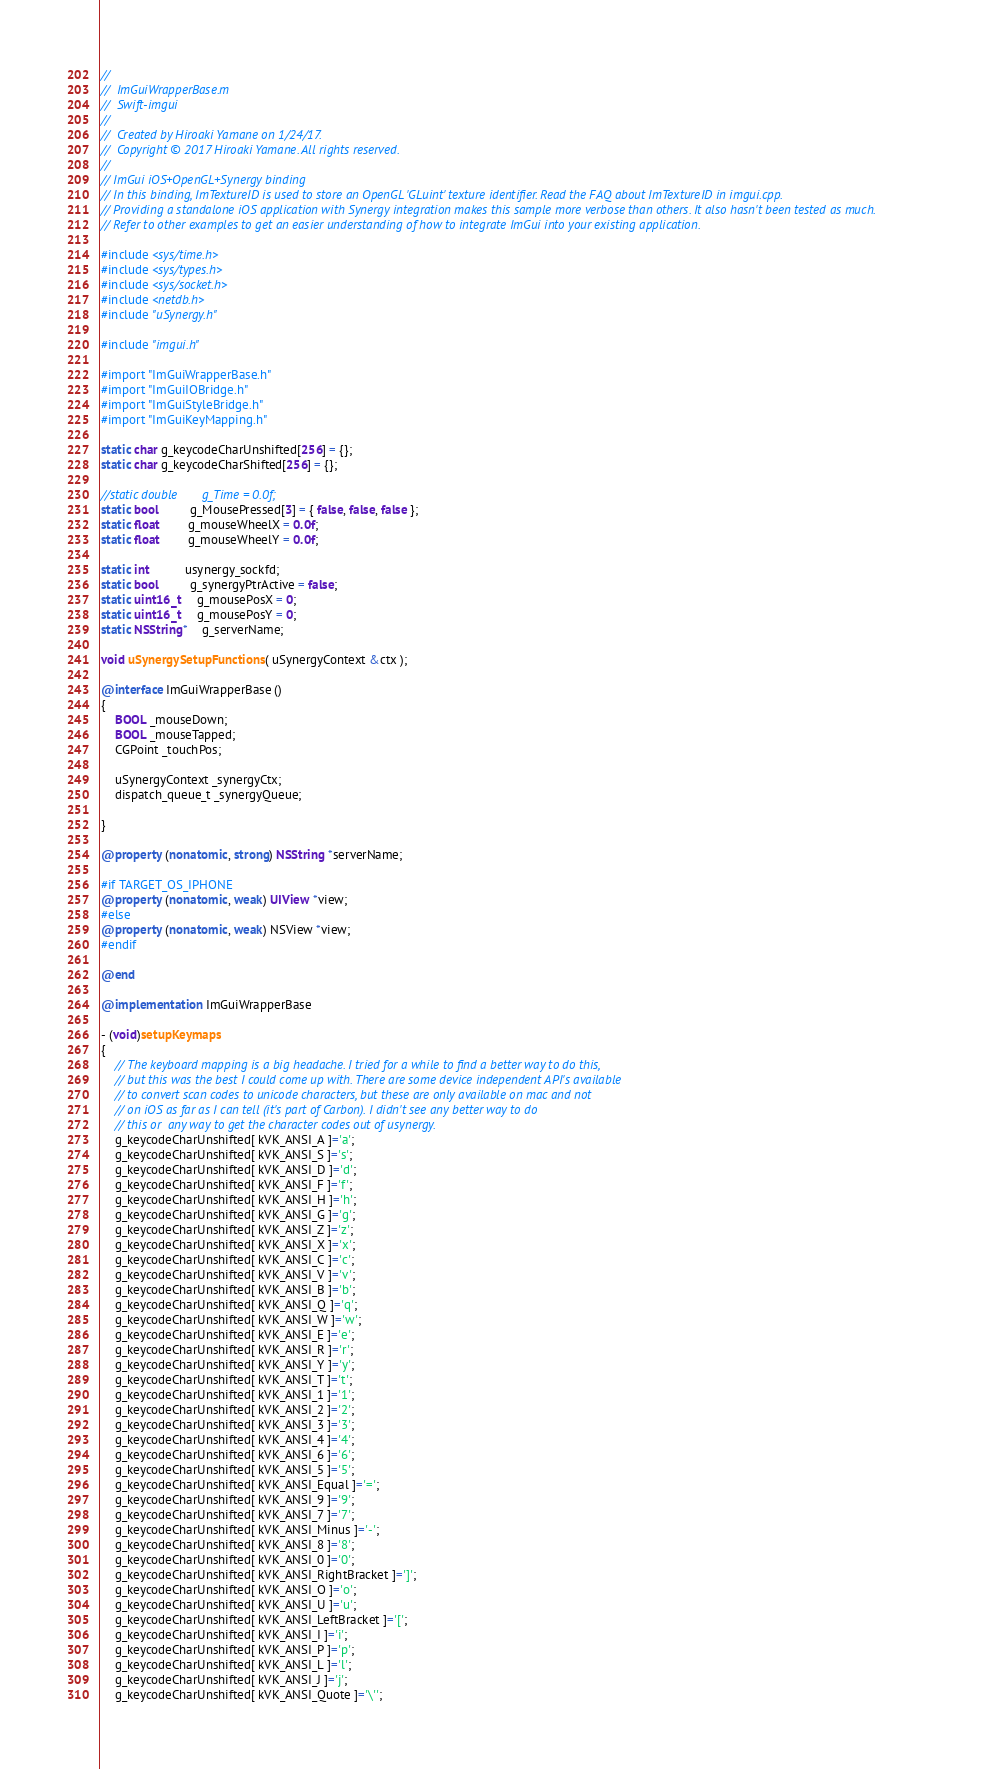Convert code to text. <code><loc_0><loc_0><loc_500><loc_500><_ObjectiveC_>//
//  ImGuiWrapperBase.m
//  Swift-imgui
//
//  Created by Hiroaki Yamane on 1/24/17.
//  Copyright © 2017 Hiroaki Yamane. All rights reserved.
//
// ImGui iOS+OpenGL+Synergy binding
// In this binding, ImTextureID is used to store an OpenGL 'GLuint' texture identifier. Read the FAQ about ImTextureID in imgui.cpp.
// Providing a standalone iOS application with Synergy integration makes this sample more verbose than others. It also hasn't been tested as much.
// Refer to other examples to get an easier understanding of how to integrate ImGui into your existing application.

#include <sys/time.h>
#include <sys/types.h>
#include <sys/socket.h>
#include <netdb.h>
#include "uSynergy.h"

#include "imgui.h"

#import "ImGuiWrapperBase.h"
#import "ImGuiIOBridge.h"
#import "ImGuiStyleBridge.h"
#import "ImGuiKeyMapping.h"

static char g_keycodeCharUnshifted[256] = {};
static char g_keycodeCharShifted[256] = {};

//static double       g_Time = 0.0f;
static bool         g_MousePressed[3] = { false, false, false };
static float        g_mouseWheelX = 0.0f;
static float        g_mouseWheelY = 0.0f;

static int          usynergy_sockfd;
static bool         g_synergyPtrActive = false;
static uint16_t     g_mousePosX = 0;
static uint16_t     g_mousePosY = 0;
static NSString*    g_serverName;

void uSynergySetupFunctions( uSynergyContext &ctx );

@interface ImGuiWrapperBase ()
{
    BOOL _mouseDown;
    BOOL _mouseTapped;
    CGPoint _touchPos;
    
    uSynergyContext _synergyCtx;
    dispatch_queue_t _synergyQueue;
    
}

@property (nonatomic, strong) NSString *serverName;

#if TARGET_OS_IPHONE
@property (nonatomic, weak) UIView *view;
#else
@property (nonatomic, weak) NSView *view;
#endif

@end

@implementation ImGuiWrapperBase

- (void)setupKeymaps
{
    // The keyboard mapping is a big headache. I tried for a while to find a better way to do this,
    // but this was the best I could come up with. There are some device independent API's available
    // to convert scan codes to unicode characters, but these are only available on mac and not
    // on iOS as far as I can tell (it's part of Carbon). I didn't see any better way to do
    // this or  any way to get the character codes out of usynergy.
    g_keycodeCharUnshifted[ kVK_ANSI_A ]='a';
    g_keycodeCharUnshifted[ kVK_ANSI_S ]='s';
    g_keycodeCharUnshifted[ kVK_ANSI_D ]='d';
    g_keycodeCharUnshifted[ kVK_ANSI_F ]='f';
    g_keycodeCharUnshifted[ kVK_ANSI_H ]='h';
    g_keycodeCharUnshifted[ kVK_ANSI_G ]='g';
    g_keycodeCharUnshifted[ kVK_ANSI_Z ]='z';
    g_keycodeCharUnshifted[ kVK_ANSI_X ]='x';
    g_keycodeCharUnshifted[ kVK_ANSI_C ]='c';
    g_keycodeCharUnshifted[ kVK_ANSI_V ]='v';
    g_keycodeCharUnshifted[ kVK_ANSI_B ]='b';
    g_keycodeCharUnshifted[ kVK_ANSI_Q ]='q';
    g_keycodeCharUnshifted[ kVK_ANSI_W ]='w';
    g_keycodeCharUnshifted[ kVK_ANSI_E ]='e';
    g_keycodeCharUnshifted[ kVK_ANSI_R ]='r';
    g_keycodeCharUnshifted[ kVK_ANSI_Y ]='y';
    g_keycodeCharUnshifted[ kVK_ANSI_T ]='t';
    g_keycodeCharUnshifted[ kVK_ANSI_1 ]='1';
    g_keycodeCharUnshifted[ kVK_ANSI_2 ]='2';
    g_keycodeCharUnshifted[ kVK_ANSI_3 ]='3';
    g_keycodeCharUnshifted[ kVK_ANSI_4 ]='4';
    g_keycodeCharUnshifted[ kVK_ANSI_6 ]='6';
    g_keycodeCharUnshifted[ kVK_ANSI_5 ]='5';
    g_keycodeCharUnshifted[ kVK_ANSI_Equal ]='=';
    g_keycodeCharUnshifted[ kVK_ANSI_9 ]='9';
    g_keycodeCharUnshifted[ kVK_ANSI_7 ]='7';
    g_keycodeCharUnshifted[ kVK_ANSI_Minus ]='-';
    g_keycodeCharUnshifted[ kVK_ANSI_8 ]='8';
    g_keycodeCharUnshifted[ kVK_ANSI_0 ]='0';
    g_keycodeCharUnshifted[ kVK_ANSI_RightBracket ]=']';
    g_keycodeCharUnshifted[ kVK_ANSI_O ]='o';
    g_keycodeCharUnshifted[ kVK_ANSI_U ]='u';
    g_keycodeCharUnshifted[ kVK_ANSI_LeftBracket ]='[';
    g_keycodeCharUnshifted[ kVK_ANSI_I ]='i';
    g_keycodeCharUnshifted[ kVK_ANSI_P ]='p';
    g_keycodeCharUnshifted[ kVK_ANSI_L ]='l';
    g_keycodeCharUnshifted[ kVK_ANSI_J ]='j';
    g_keycodeCharUnshifted[ kVK_ANSI_Quote ]='\'';</code> 